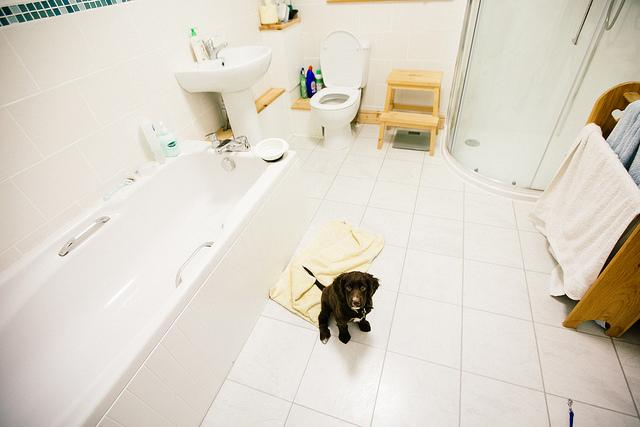Why might the dog be near the tub?

Choices:
A) to bathe
B) to guard
C) to play
D) to eat to bathe 